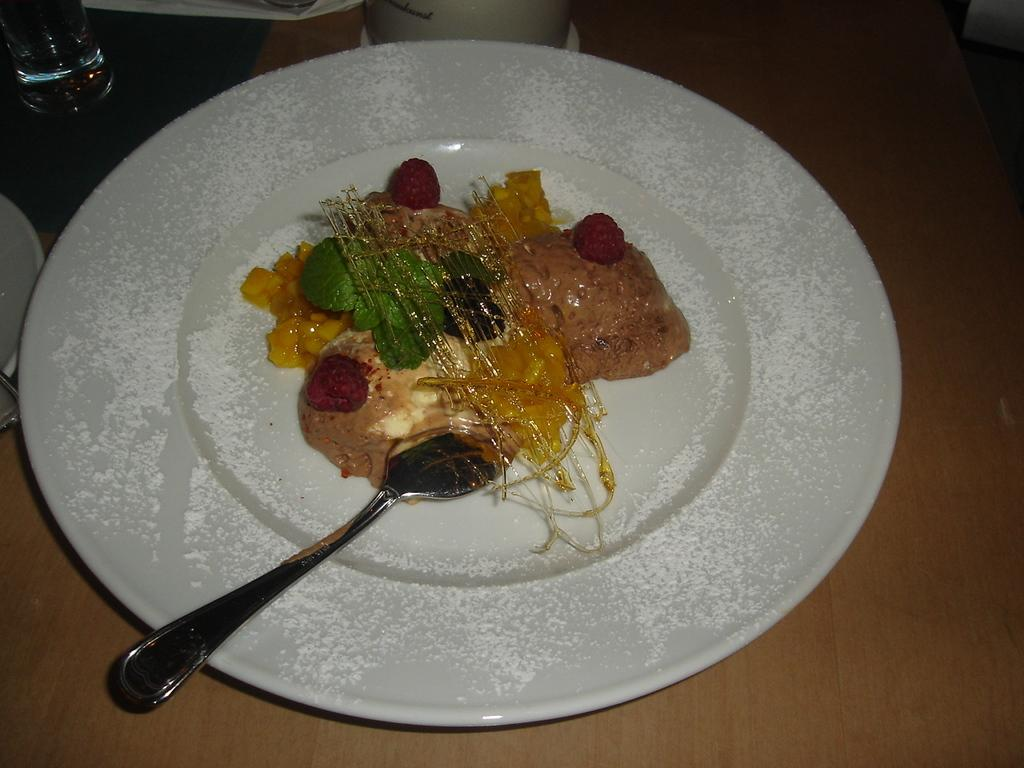What types of food items can be seen in the image? There are food items in the image, but their specific types cannot be determined from the provided facts. What utensil is placed on a plate in the image? There is a spoon on a plate in the image. What type of container is visible in the image? There is a glass visible in the image. What type of smile can be seen on the food items in the image? There is no smile present on the food items in the image, as they are inanimate objects and cannot display emotions. 